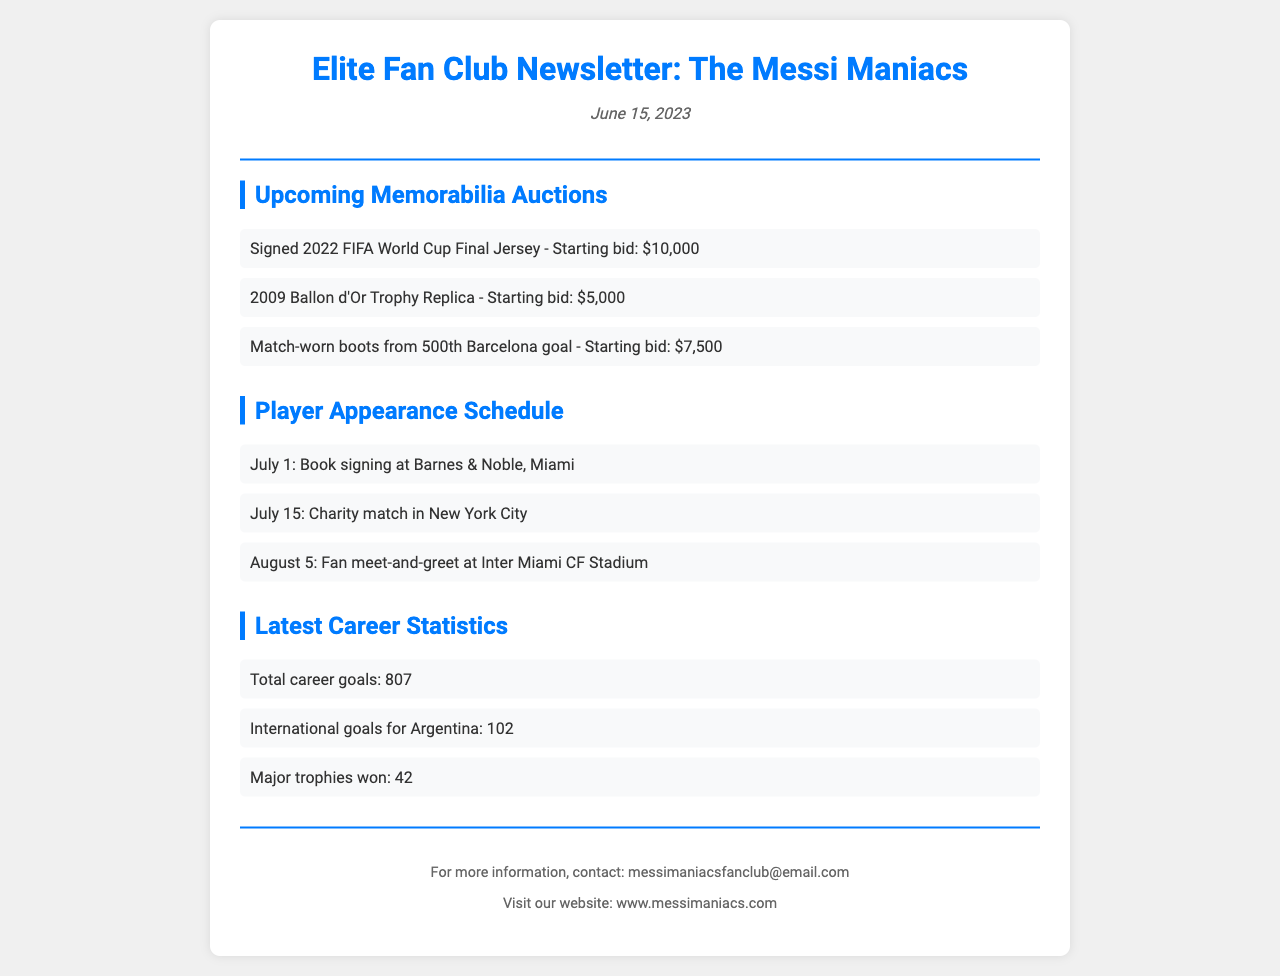What is the date of the newsletter? The date is provided prominently at the top of the document.
Answer: June 15, 2023 What is the starting bid for the signed 2022 FIFA World Cup Final Jersey? The starting bid for this item is listed under the memorabilia auction section.
Answer: $10,000 How many major trophies has Messi won? The number of major trophies is stated in the latest career statistics section of the document.
Answer: 42 When is the charity match scheduled? The date for the charity match is found in the player appearance schedule section.
Answer: July 15 What is the total career goals scored by Messi? The total career goals are presented in the latest career statistics.
Answer: 807 Where is the book signing event taking place? The location of the book signing is mentioned in the player appearance schedule.
Answer: Miami What type of memorabilia auction item is the 2009 Ballon d'Or Trophy? This specific item is categorized under the upcoming memorabilia auctions section.
Answer: Trophy Replica What is the email contact for the fan club? The email contact is included in the footer section of the document.
Answer: messimaniacsfanclub@email.com 